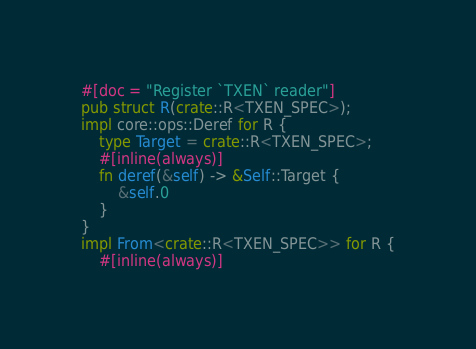<code> <loc_0><loc_0><loc_500><loc_500><_Rust_>#[doc = "Register `TXEN` reader"]
pub struct R(crate::R<TXEN_SPEC>);
impl core::ops::Deref for R {
    type Target = crate::R<TXEN_SPEC>;
    #[inline(always)]
    fn deref(&self) -> &Self::Target {
        &self.0
    }
}
impl From<crate::R<TXEN_SPEC>> for R {
    #[inline(always)]</code> 